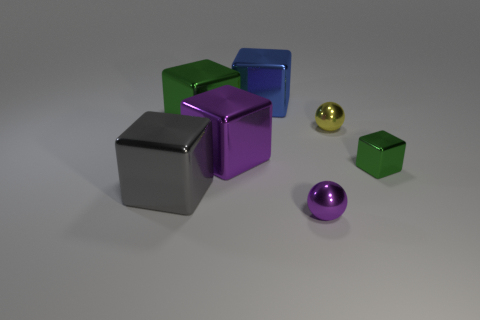Subtract all big gray blocks. How many blocks are left? 4 Add 2 big brown rubber spheres. How many objects exist? 9 Subtract all blue cubes. How many cubes are left? 4 Subtract all brown balls. How many green blocks are left? 2 Subtract all blocks. How many objects are left? 2 Subtract all yellow objects. Subtract all large green shiny cubes. How many objects are left? 5 Add 5 big shiny things. How many big shiny things are left? 9 Add 2 large green metal blocks. How many large green metal blocks exist? 3 Subtract 0 red cylinders. How many objects are left? 7 Subtract all gray blocks. Subtract all cyan spheres. How many blocks are left? 4 